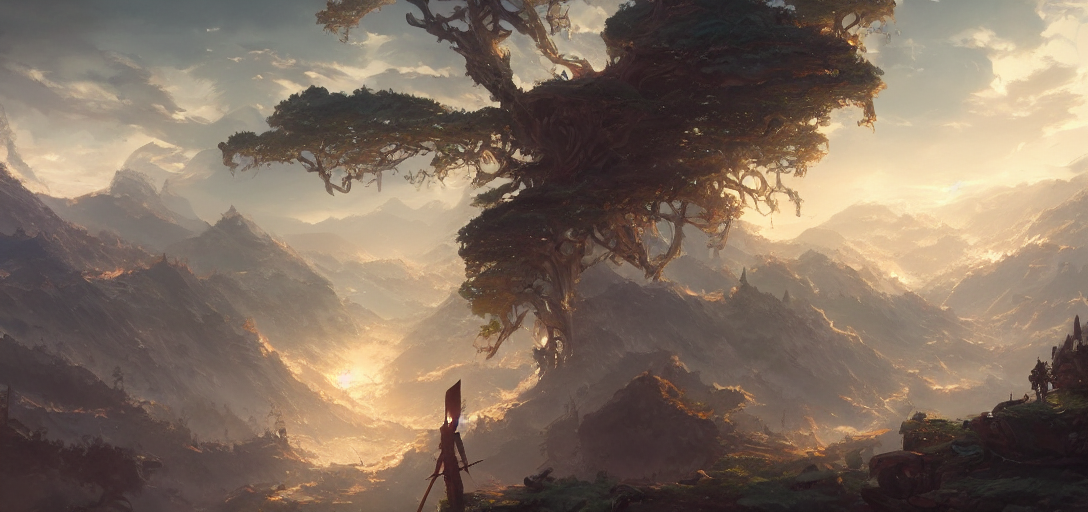Why is the content somewhat blurry?
A. Sharp
B. Unclear
C. In focus
Answer with the option's letter from the given choices directly. The correct answer to why the content is somewhat blurry is B, meaning the content is unclear. The image revealed a beautiful yet hazy landscape, likely indicating the distance or an artistic choice to create a sense of mystery and depth. 